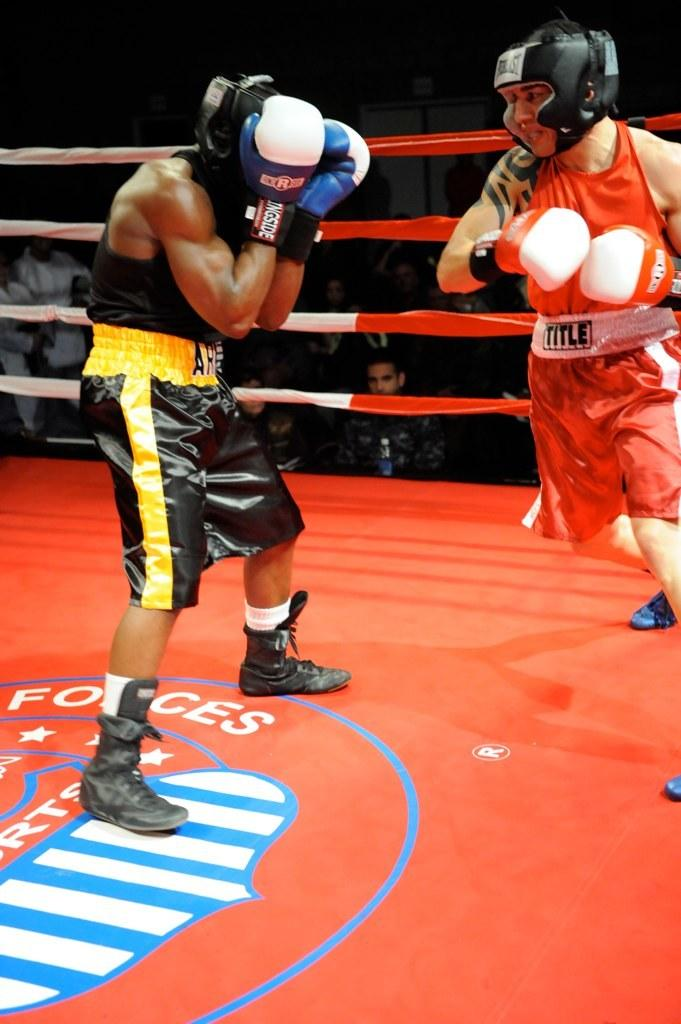<image>
Write a terse but informative summary of the picture. The boxer in red looks like he wants the title according to his belt. 